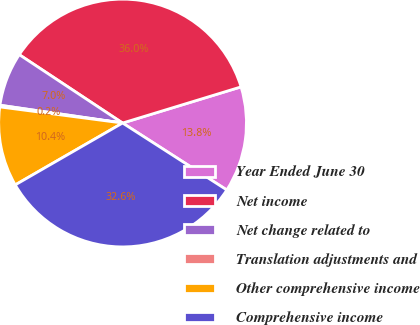Convert chart. <chart><loc_0><loc_0><loc_500><loc_500><pie_chart><fcel>Year Ended June 30<fcel>Net income<fcel>Net change related to<fcel>Translation adjustments and<fcel>Other comprehensive income<fcel>Comprehensive income<nl><fcel>13.8%<fcel>35.98%<fcel>7.01%<fcel>0.22%<fcel>10.4%<fcel>32.59%<nl></chart> 